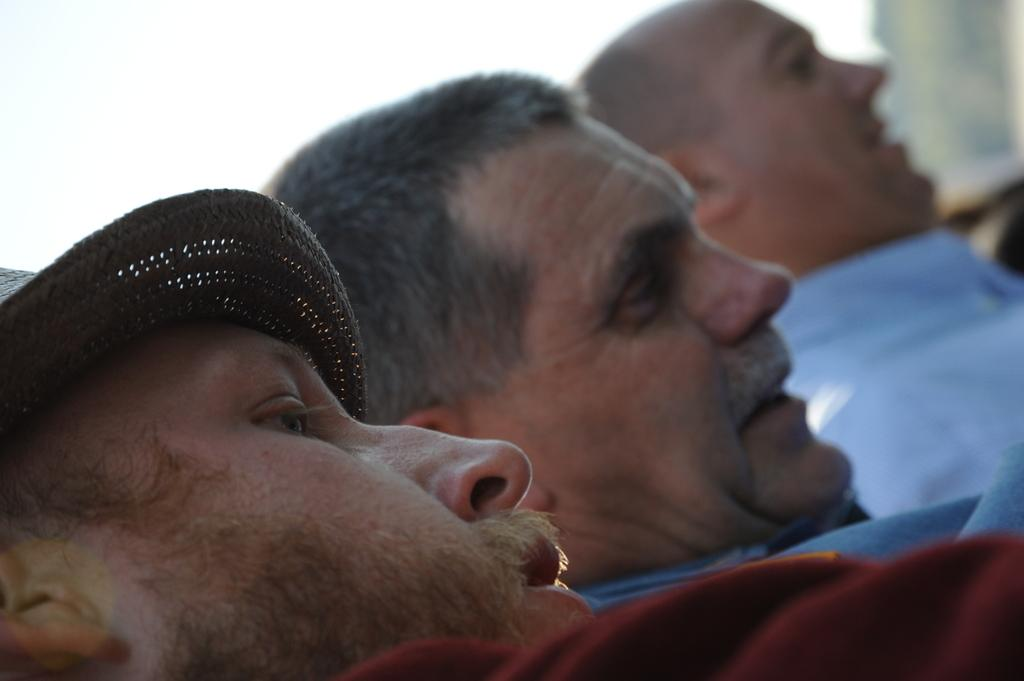How many people are in the image? There are three men in the image. What are the men wearing? The men are wearing clothes. Can you describe any specific clothing item one of the men is wearing? One of the men is wearing a cap. How would you describe the background of the image? The background of the image appears blurry. What type of cheese is being sold in the shop in the image? There is no shop or cheese present in the image. Can you tell me how many thumbs are being used by the men in the image? There is no indication of the men using their thumbs in the image. 